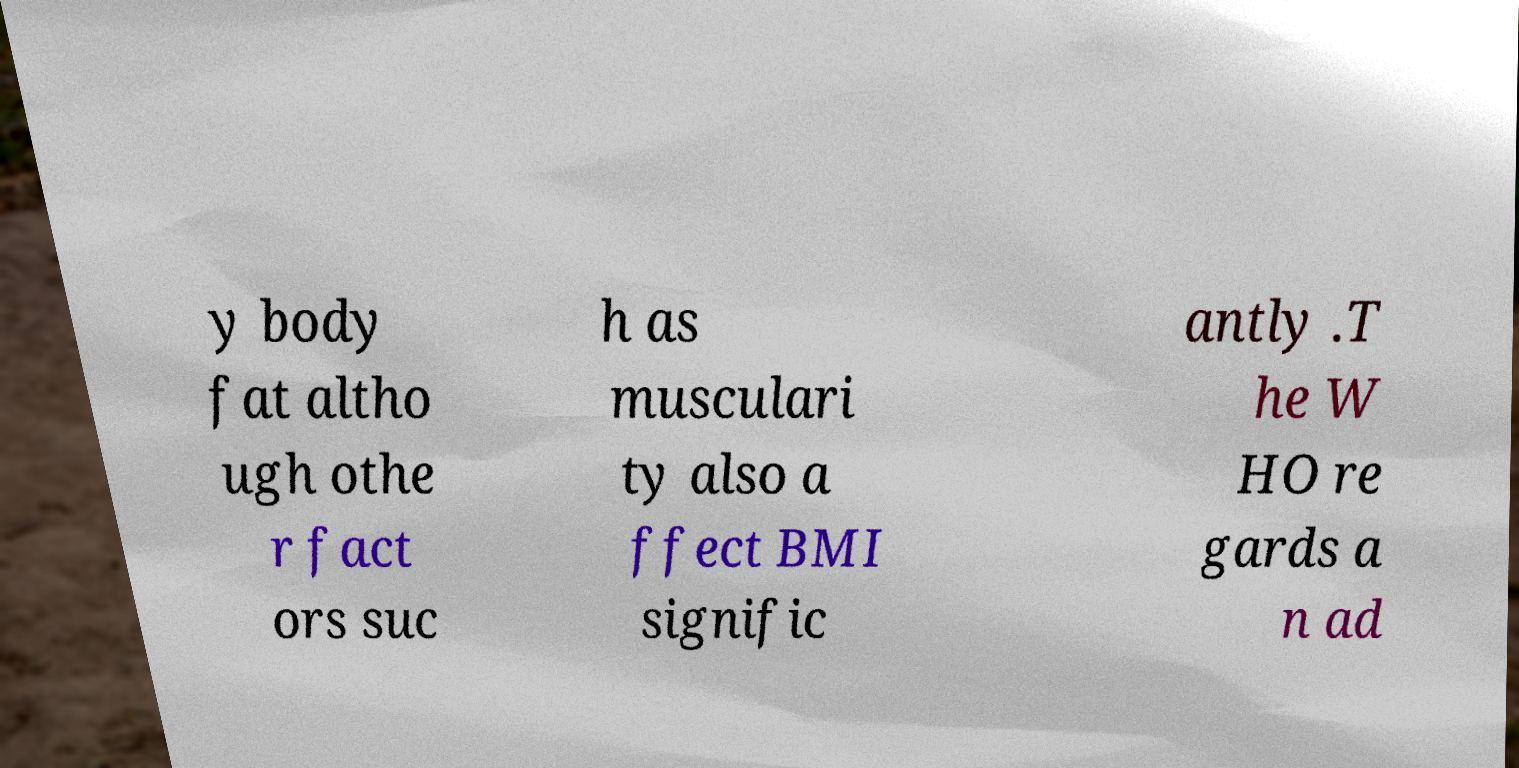Can you accurately transcribe the text from the provided image for me? y body fat altho ugh othe r fact ors suc h as musculari ty also a ffect BMI signific antly .T he W HO re gards a n ad 